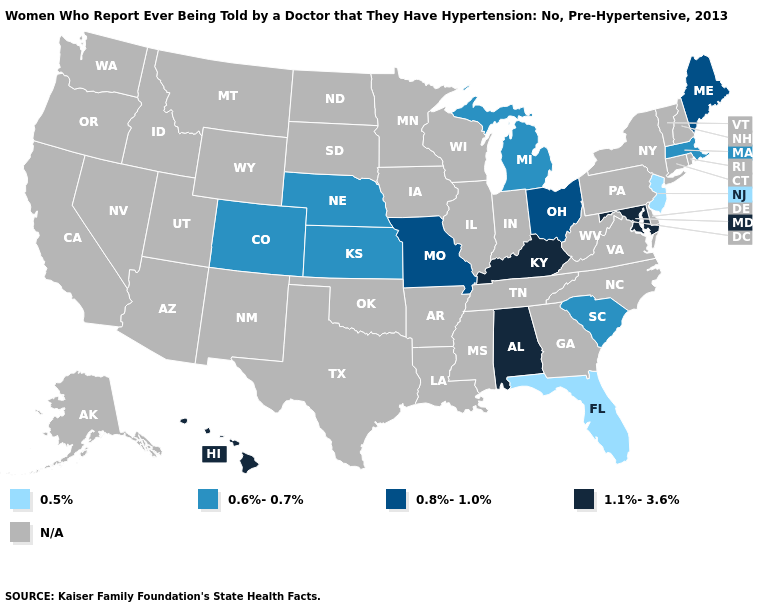What is the lowest value in the USA?
Quick response, please. 0.5%. Does the first symbol in the legend represent the smallest category?
Quick response, please. Yes. Among the states that border Delaware , does Maryland have the lowest value?
Short answer required. No. Among the states that border Kansas , does Missouri have the lowest value?
Be succinct. No. Name the states that have a value in the range 0.8%-1.0%?
Answer briefly. Maine, Missouri, Ohio. Does South Carolina have the highest value in the South?
Give a very brief answer. No. What is the value of Connecticut?
Quick response, please. N/A. What is the highest value in states that border Alabama?
Quick response, please. 0.5%. What is the value of Rhode Island?
Short answer required. N/A. Name the states that have a value in the range 0.5%?
Answer briefly. Florida, New Jersey. Does Colorado have the highest value in the West?
Give a very brief answer. No. Name the states that have a value in the range 0.8%-1.0%?
Quick response, please. Maine, Missouri, Ohio. What is the highest value in the USA?
Write a very short answer. 1.1%-3.6%. Name the states that have a value in the range 0.8%-1.0%?
Keep it brief. Maine, Missouri, Ohio. 